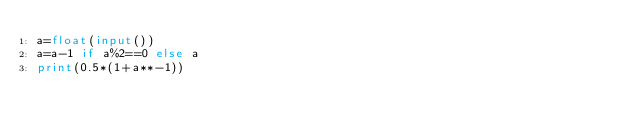<code> <loc_0><loc_0><loc_500><loc_500><_Python_>a=float(input())
a=a-1 if a%2==0 else a
print(0.5*(1+a**-1))</code> 